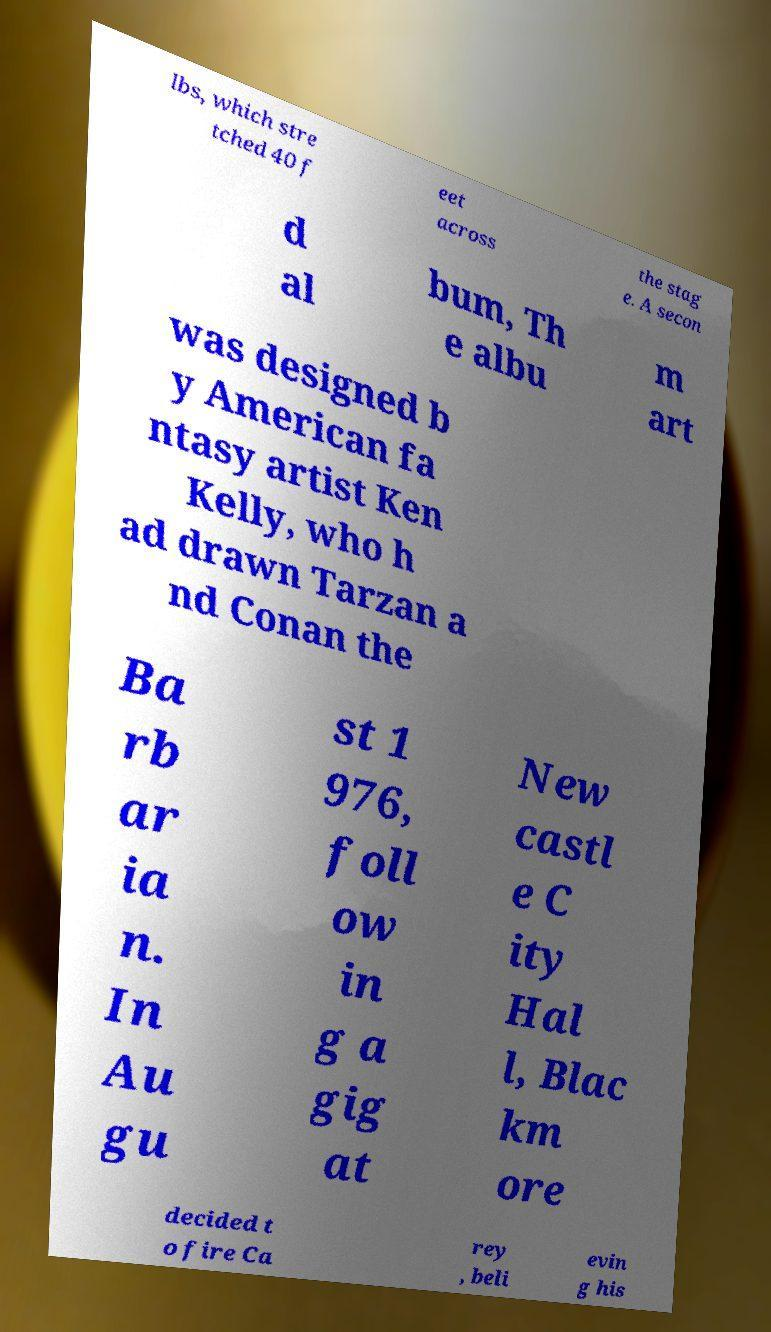For documentation purposes, I need the text within this image transcribed. Could you provide that? lbs, which stre tched 40 f eet across the stag e. A secon d al bum, Th e albu m art was designed b y American fa ntasy artist Ken Kelly, who h ad drawn Tarzan a nd Conan the Ba rb ar ia n. In Au gu st 1 976, foll ow in g a gig at New castl e C ity Hal l, Blac km ore decided t o fire Ca rey , beli evin g his 